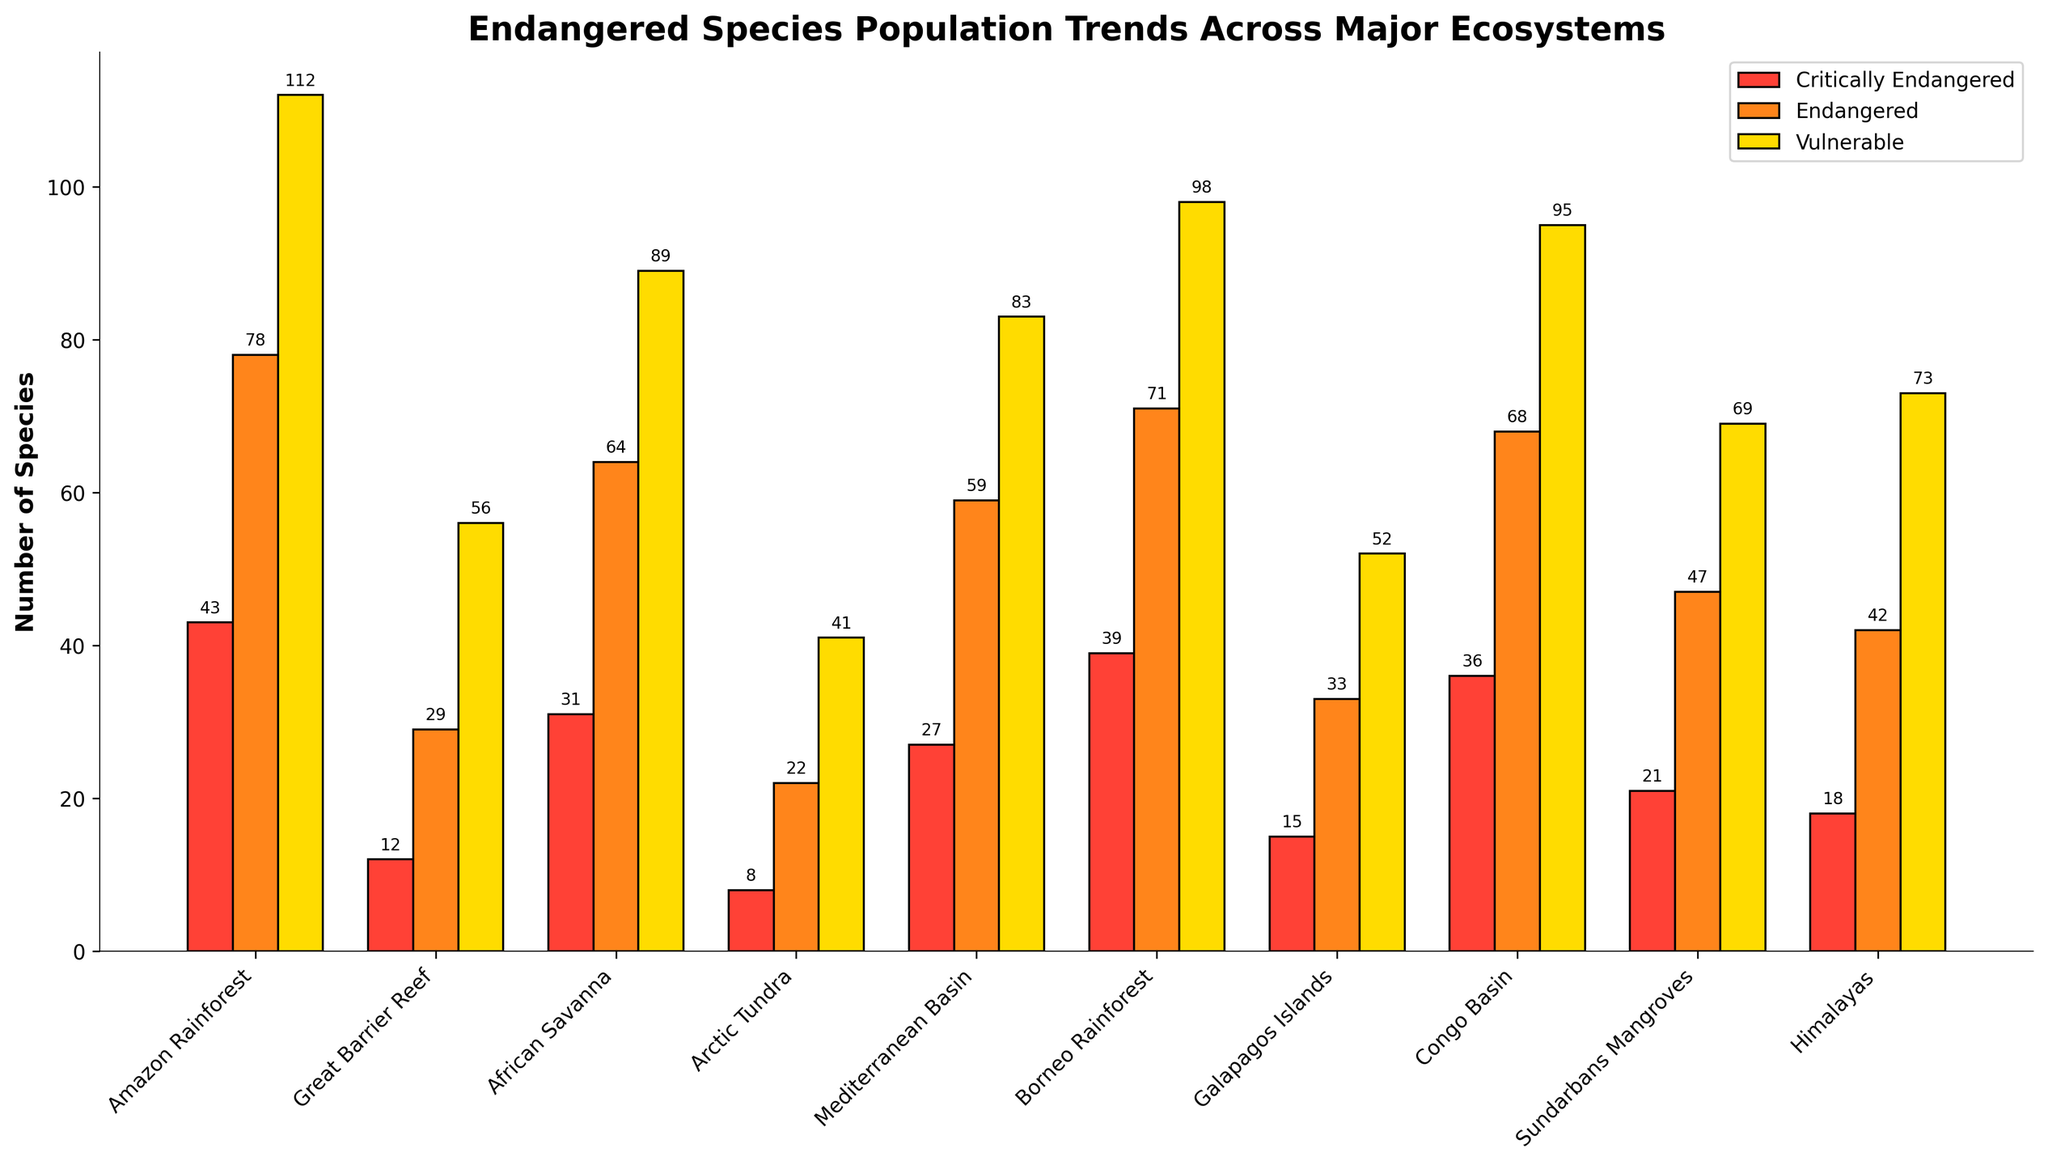What ecosystem has the highest number of critically endangered species? The bar for the Amazon Rainforest representing critically endangered species (in red) is the tallest among all ecosystems.
Answer: Amazon Rainforest Which ecosystem has the least number of vulnerable species? The bar for the Arctic Tundra representing vulnerable species (in yellow) is the shortest among all ecosystems.
Answer: Arctic Tundra What is the total number of endangered species in the African Savanna and the Amazon Rainforest combined? The Amazon Rainforest has 78 endangered species and the African Savanna has 64. Their total is 78 + 64 = 142.
Answer: 142 How many more critically endangered species are there in the Congo Basin compared to the Mediterranean Basin? The Congo Basin has 36 critically endangered species, and the Mediterranean Basin has 27. The difference is 36 - 27 = 9.
Answer: 9 How does the number of vulnerable species in the Great Barrier Reef compare to the Galapagos Islands? The bar for the vulnerable species in the Great Barrier Reef stands at 56, which is taller than the bar for the Galapagos Islands at 52.
Answer: More in the Great Barrier Reef What is the average number of critically endangered species across all ecosystems? Sum of critically endangered species across all ecosystems is 43 + 12 + 31 + 8 + 27 + 39 + 15 + 36 + 21 + 18 = 250. There are 10 ecosystems, so the average is 250 / 10 = 25.
Answer: 25 What ecosystem has the closest numbers of critically endangered and vulnerable species? Comparing the bars in each ecosystem, the Himalayas have 18 critically endangered and 73 vulnerable species, but there’s no ecosystem where the two bars are close. The closest is the Galapagos Islands with 15 critically endangered and 52 vulnerable species.
Answer: Galapagos Islands How many ecosystems have a higher number of endangered species than vulnerable species? By comparing the heights of the orange (endangered) bars to the yellow (vulnerable) bars for each ecosystem, none of the ecosystems have a higher number of endangered species than vulnerable species.
Answer: 0 Does the Amazon Rainforest have more critically endangered species than the sum of those in the Great Barrier Reef and Himalayas? The Amazon Rainforest has 43 critically endangered species. The Great Barrier Reef has 12 and the Himalayas have 18, summing up to 12 + 18 = 30. 43 is greater than 30.
Answer: Yes 